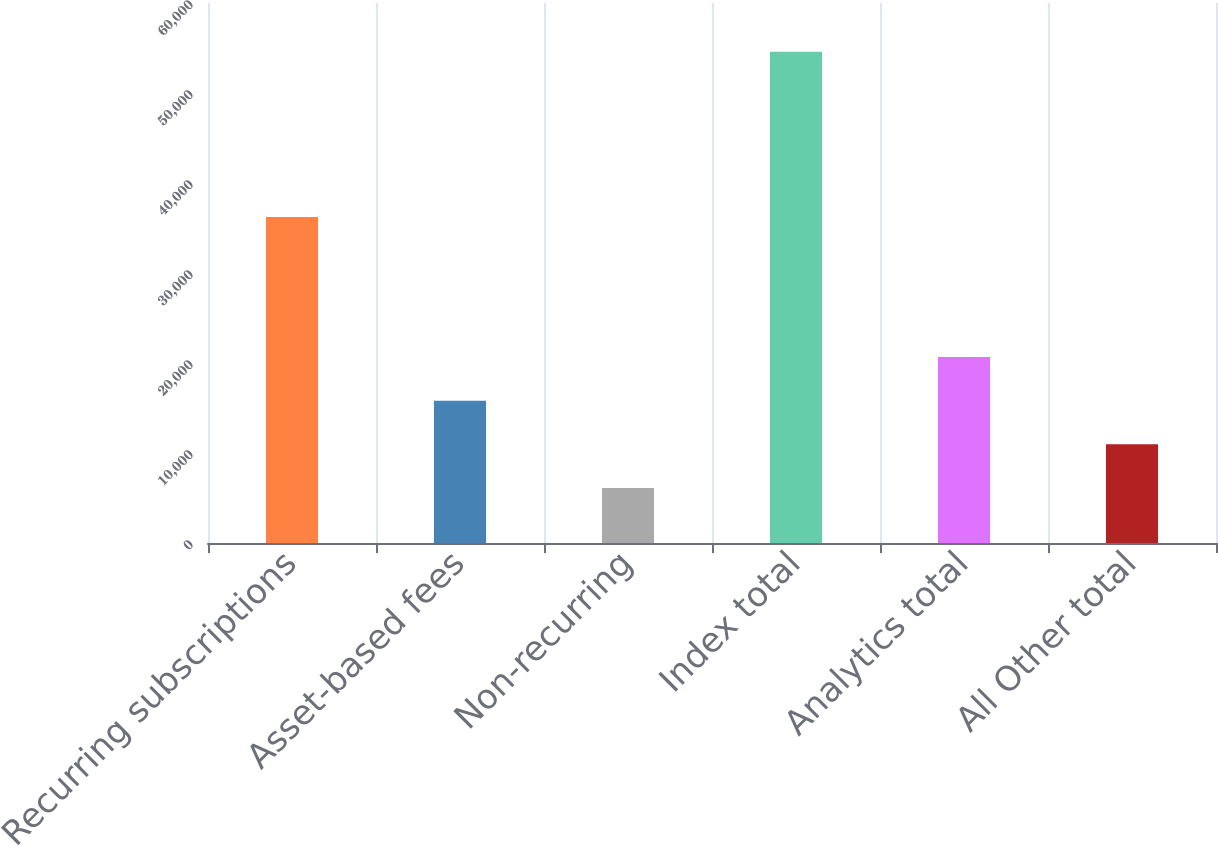<chart> <loc_0><loc_0><loc_500><loc_500><bar_chart><fcel>Recurring subscriptions<fcel>Asset-based fees<fcel>Non-recurring<fcel>Index total<fcel>Analytics total<fcel>All Other total<nl><fcel>36212<fcel>15813.4<fcel>6120<fcel>54587<fcel>20660.1<fcel>10966.7<nl></chart> 